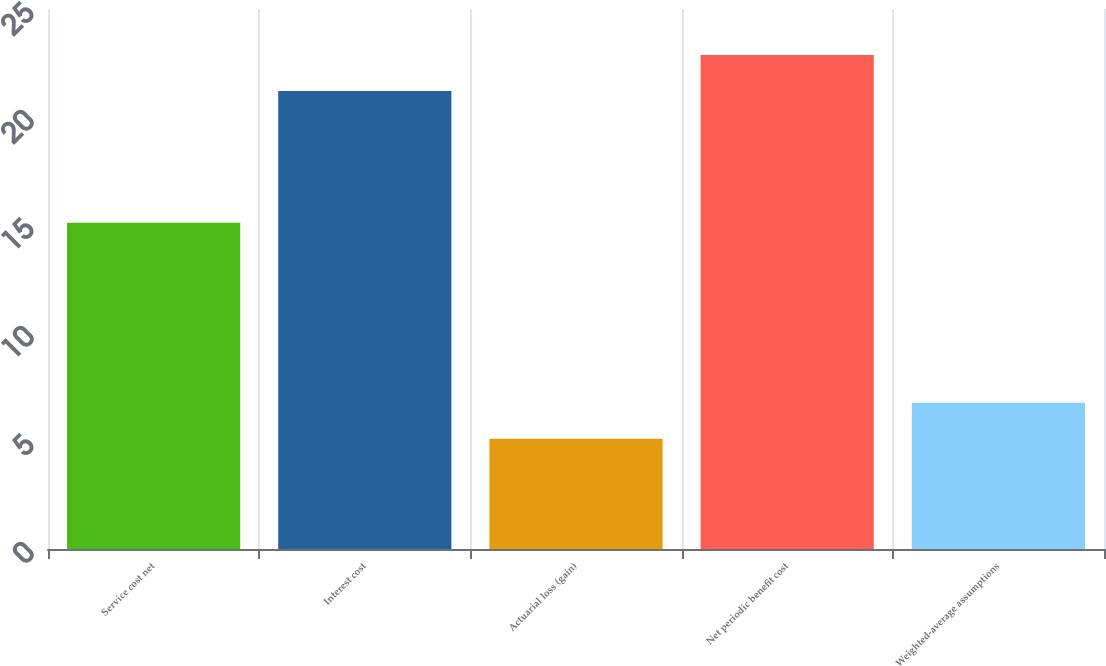<chart> <loc_0><loc_0><loc_500><loc_500><bar_chart><fcel>Service cost net<fcel>Interest cost<fcel>Actuarial loss (gain)<fcel>Net periodic benefit cost<fcel>Weighted-average assumptions<nl><fcel>15.1<fcel>21.2<fcel>5.1<fcel>22.87<fcel>6.77<nl></chart> 